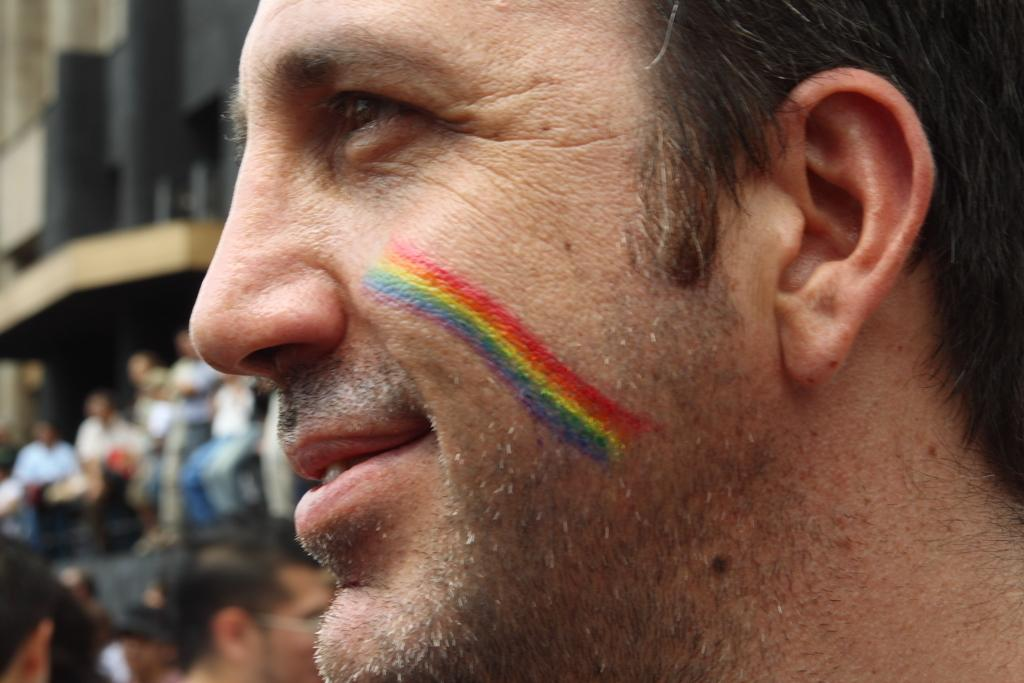What is the main activity of the people in the image? The people in the image are standing and some are seated. What type of structure can be seen in the background? There is a building visible in the image. Can you describe the man in the image? The man in the image has a painting on his face. What type of haircut does the beggar in the image have? There is no beggar present in the image, and therefore no haircut can be described. What shape is the square in the image? There is no square present in the image. 